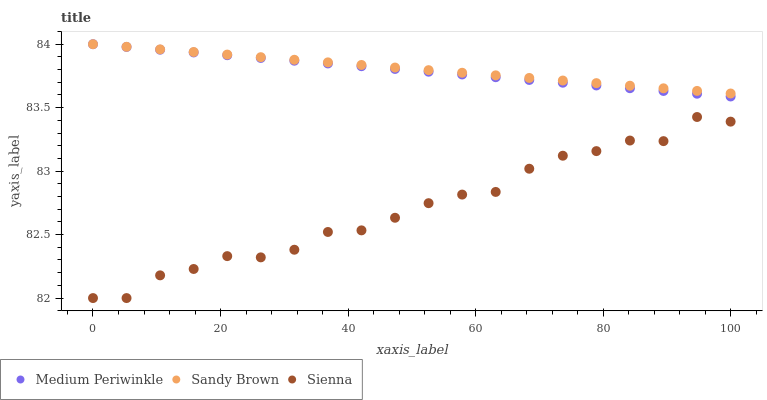Does Sienna have the minimum area under the curve?
Answer yes or no. Yes. Does Sandy Brown have the maximum area under the curve?
Answer yes or no. Yes. Does Medium Periwinkle have the minimum area under the curve?
Answer yes or no. No. Does Medium Periwinkle have the maximum area under the curve?
Answer yes or no. No. Is Medium Periwinkle the smoothest?
Answer yes or no. Yes. Is Sienna the roughest?
Answer yes or no. Yes. Is Sandy Brown the smoothest?
Answer yes or no. No. Is Sandy Brown the roughest?
Answer yes or no. No. Does Sienna have the lowest value?
Answer yes or no. Yes. Does Medium Periwinkle have the lowest value?
Answer yes or no. No. Does Medium Periwinkle have the highest value?
Answer yes or no. Yes. Is Sienna less than Medium Periwinkle?
Answer yes or no. Yes. Is Sandy Brown greater than Sienna?
Answer yes or no. Yes. Does Sandy Brown intersect Medium Periwinkle?
Answer yes or no. Yes. Is Sandy Brown less than Medium Periwinkle?
Answer yes or no. No. Is Sandy Brown greater than Medium Periwinkle?
Answer yes or no. No. Does Sienna intersect Medium Periwinkle?
Answer yes or no. No. 